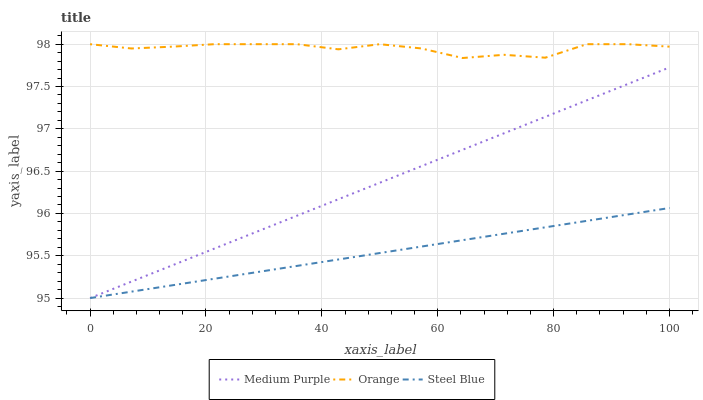Does Orange have the minimum area under the curve?
Answer yes or no. No. Does Steel Blue have the maximum area under the curve?
Answer yes or no. No. Is Orange the smoothest?
Answer yes or no. No. Is Steel Blue the roughest?
Answer yes or no. No. Does Orange have the lowest value?
Answer yes or no. No. Does Steel Blue have the highest value?
Answer yes or no. No. Is Medium Purple less than Orange?
Answer yes or no. Yes. Is Orange greater than Medium Purple?
Answer yes or no. Yes. Does Medium Purple intersect Orange?
Answer yes or no. No. 